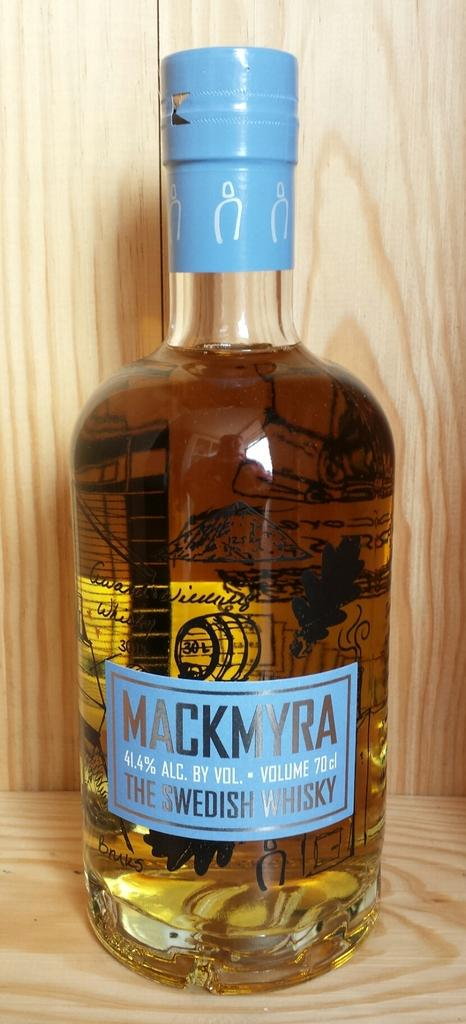<image>
Write a terse but informative summary of the picture. A bottle of Mackmyra the Swedish Whiskey with 41.1% Alc. by Volume 70 cl. 